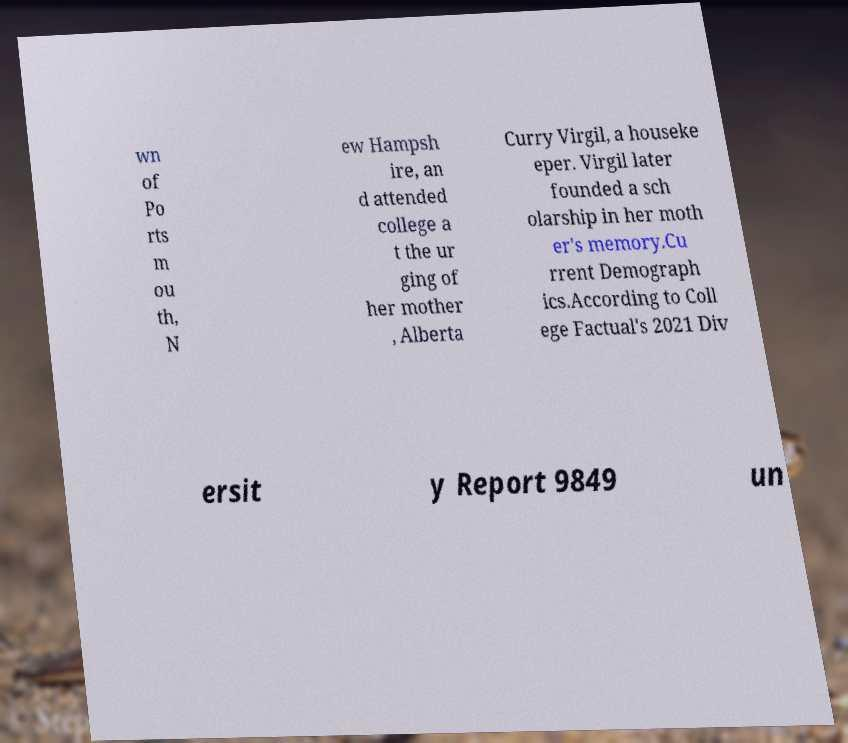What messages or text are displayed in this image? I need them in a readable, typed format. wn of Po rts m ou th, N ew Hampsh ire, an d attended college a t the ur ging of her mother , Alberta Curry Virgil, a houseke eper. Virgil later founded a sch olarship in her moth er's memory.Cu rrent Demograph ics.According to Coll ege Factual's 2021 Div ersit y Report 9849 un 